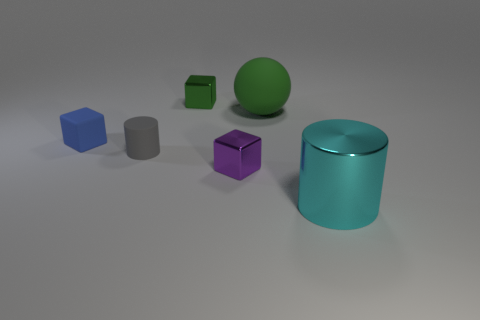Are there fewer blue rubber cubes behind the gray object than shiny things that are right of the green cube? Yes, there are fewer blue rubber cubes behind the gray object compared to the number of shiny things to the right of the green cube. To be more specific, we can see one blue cube behind the gray cylinder and two shiny objects, a sphere and a cylinder, to the right of the green cube. 